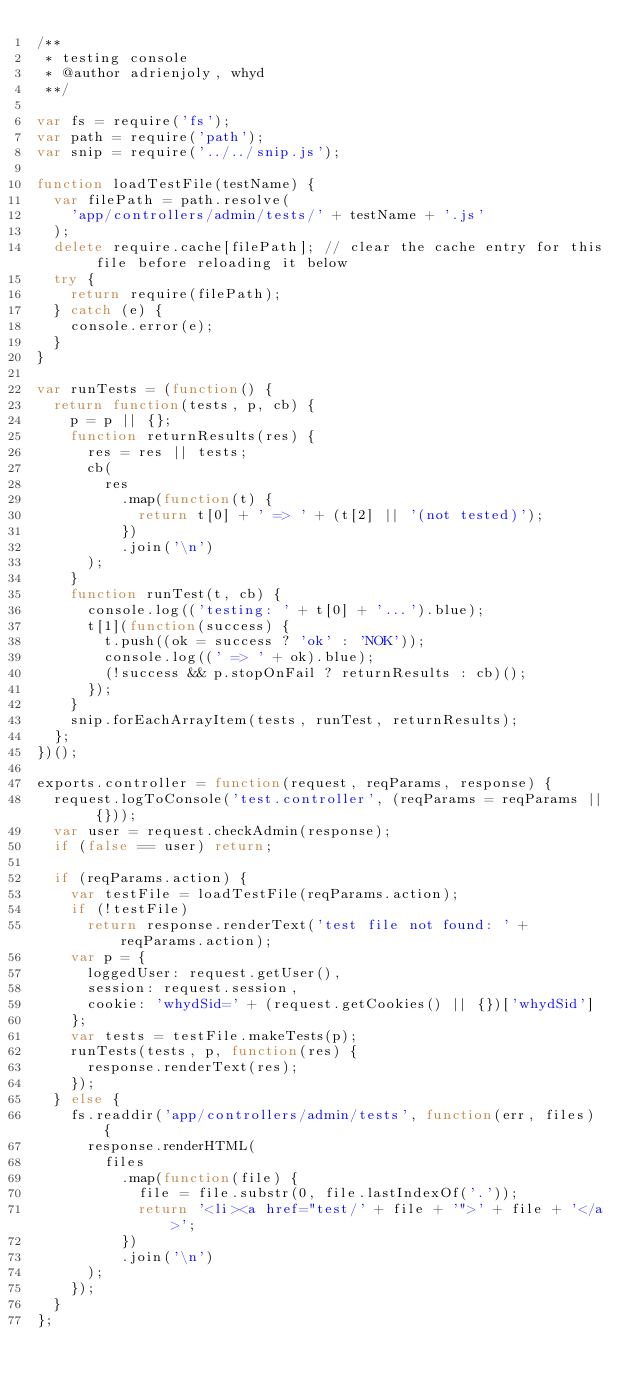Convert code to text. <code><loc_0><loc_0><loc_500><loc_500><_JavaScript_>/**
 * testing console
 * @author adrienjoly, whyd
 **/

var fs = require('fs');
var path = require('path');
var snip = require('../../snip.js');

function loadTestFile(testName) {
  var filePath = path.resolve(
    'app/controllers/admin/tests/' + testName + '.js'
  );
  delete require.cache[filePath]; // clear the cache entry for this file before reloading it below
  try {
    return require(filePath);
  } catch (e) {
    console.error(e);
  }
}

var runTests = (function() {
  return function(tests, p, cb) {
    p = p || {};
    function returnResults(res) {
      res = res || tests;
      cb(
        res
          .map(function(t) {
            return t[0] + ' => ' + (t[2] || '(not tested)');
          })
          .join('\n')
      );
    }
    function runTest(t, cb) {
      console.log(('testing: ' + t[0] + '...').blue);
      t[1](function(success) {
        t.push((ok = success ? 'ok' : 'NOK'));
        console.log((' => ' + ok).blue);
        (!success && p.stopOnFail ? returnResults : cb)();
      });
    }
    snip.forEachArrayItem(tests, runTest, returnResults);
  };
})();

exports.controller = function(request, reqParams, response) {
  request.logToConsole('test.controller', (reqParams = reqParams || {}));
  var user = request.checkAdmin(response);
  if (false == user) return;

  if (reqParams.action) {
    var testFile = loadTestFile(reqParams.action);
    if (!testFile)
      return response.renderText('test file not found: ' + reqParams.action);
    var p = {
      loggedUser: request.getUser(),
      session: request.session,
      cookie: 'whydSid=' + (request.getCookies() || {})['whydSid']
    };
    var tests = testFile.makeTests(p);
    runTests(tests, p, function(res) {
      response.renderText(res);
    });
  } else {
    fs.readdir('app/controllers/admin/tests', function(err, files) {
      response.renderHTML(
        files
          .map(function(file) {
            file = file.substr(0, file.lastIndexOf('.'));
            return '<li><a href="test/' + file + '">' + file + '</a>';
          })
          .join('\n')
      );
    });
  }
};
</code> 